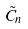Convert formula to latex. <formula><loc_0><loc_0><loc_500><loc_500>\tilde { C } _ { n }</formula> 